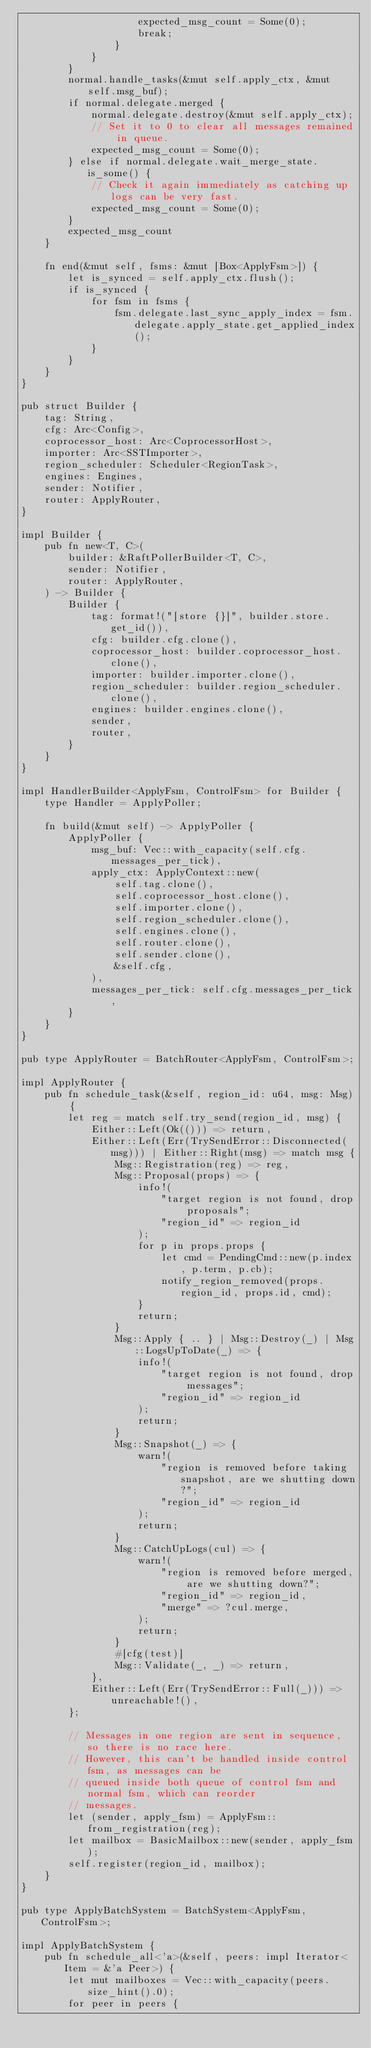Convert code to text. <code><loc_0><loc_0><loc_500><loc_500><_Rust_>                    expected_msg_count = Some(0);
                    break;
                }
            }
        }
        normal.handle_tasks(&mut self.apply_ctx, &mut self.msg_buf);
        if normal.delegate.merged {
            normal.delegate.destroy(&mut self.apply_ctx);
            // Set it to 0 to clear all messages remained in queue.
            expected_msg_count = Some(0);
        } else if normal.delegate.wait_merge_state.is_some() {
            // Check it again immediately as catching up logs can be very fast.
            expected_msg_count = Some(0);
        }
        expected_msg_count
    }

    fn end(&mut self, fsms: &mut [Box<ApplyFsm>]) {
        let is_synced = self.apply_ctx.flush();
        if is_synced {
            for fsm in fsms {
                fsm.delegate.last_sync_apply_index = fsm.delegate.apply_state.get_applied_index();
            }
        }
    }
}

pub struct Builder {
    tag: String,
    cfg: Arc<Config>,
    coprocessor_host: Arc<CoprocessorHost>,
    importer: Arc<SSTImporter>,
    region_scheduler: Scheduler<RegionTask>,
    engines: Engines,
    sender: Notifier,
    router: ApplyRouter,
}

impl Builder {
    pub fn new<T, C>(
        builder: &RaftPollerBuilder<T, C>,
        sender: Notifier,
        router: ApplyRouter,
    ) -> Builder {
        Builder {
            tag: format!("[store {}]", builder.store.get_id()),
            cfg: builder.cfg.clone(),
            coprocessor_host: builder.coprocessor_host.clone(),
            importer: builder.importer.clone(),
            region_scheduler: builder.region_scheduler.clone(),
            engines: builder.engines.clone(),
            sender,
            router,
        }
    }
}

impl HandlerBuilder<ApplyFsm, ControlFsm> for Builder {
    type Handler = ApplyPoller;

    fn build(&mut self) -> ApplyPoller {
        ApplyPoller {
            msg_buf: Vec::with_capacity(self.cfg.messages_per_tick),
            apply_ctx: ApplyContext::new(
                self.tag.clone(),
                self.coprocessor_host.clone(),
                self.importer.clone(),
                self.region_scheduler.clone(),
                self.engines.clone(),
                self.router.clone(),
                self.sender.clone(),
                &self.cfg,
            ),
            messages_per_tick: self.cfg.messages_per_tick,
        }
    }
}

pub type ApplyRouter = BatchRouter<ApplyFsm, ControlFsm>;

impl ApplyRouter {
    pub fn schedule_task(&self, region_id: u64, msg: Msg) {
        let reg = match self.try_send(region_id, msg) {
            Either::Left(Ok(())) => return,
            Either::Left(Err(TrySendError::Disconnected(msg))) | Either::Right(msg) => match msg {
                Msg::Registration(reg) => reg,
                Msg::Proposal(props) => {
                    info!(
                        "target region is not found, drop proposals";
                        "region_id" => region_id
                    );
                    for p in props.props {
                        let cmd = PendingCmd::new(p.index, p.term, p.cb);
                        notify_region_removed(props.region_id, props.id, cmd);
                    }
                    return;
                }
                Msg::Apply { .. } | Msg::Destroy(_) | Msg::LogsUpToDate(_) => {
                    info!(
                        "target region is not found, drop messages";
                        "region_id" => region_id
                    );
                    return;
                }
                Msg::Snapshot(_) => {
                    warn!(
                        "region is removed before taking snapshot, are we shutting down?";
                        "region_id" => region_id
                    );
                    return;
                }
                Msg::CatchUpLogs(cul) => {
                    warn!(
                        "region is removed before merged, are we shutting down?";
                        "region_id" => region_id,
                        "merge" => ?cul.merge,
                    );
                    return;
                }
                #[cfg(test)]
                Msg::Validate(_, _) => return,
            },
            Either::Left(Err(TrySendError::Full(_))) => unreachable!(),
        };

        // Messages in one region are sent in sequence, so there is no race here.
        // However, this can't be handled inside control fsm, as messages can be
        // queued inside both queue of control fsm and normal fsm, which can reorder
        // messages.
        let (sender, apply_fsm) = ApplyFsm::from_registration(reg);
        let mailbox = BasicMailbox::new(sender, apply_fsm);
        self.register(region_id, mailbox);
    }
}

pub type ApplyBatchSystem = BatchSystem<ApplyFsm, ControlFsm>;

impl ApplyBatchSystem {
    pub fn schedule_all<'a>(&self, peers: impl Iterator<Item = &'a Peer>) {
        let mut mailboxes = Vec::with_capacity(peers.size_hint().0);
        for peer in peers {</code> 